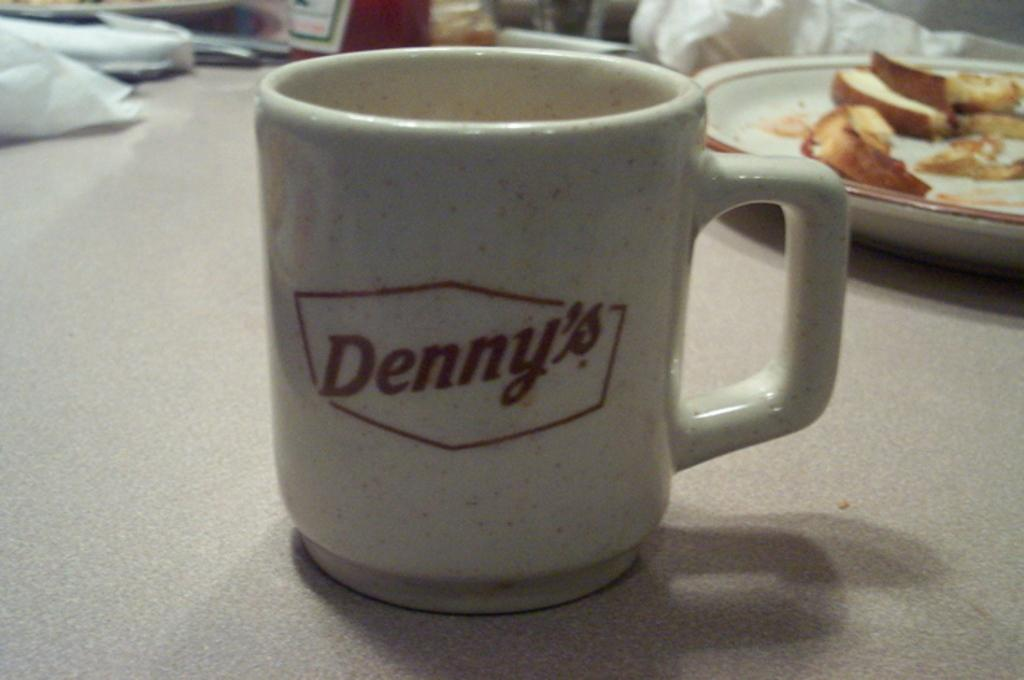Provide a one-sentence caption for the provided image. A Denny's mug is sitting on a table with a plate of eaten food. 